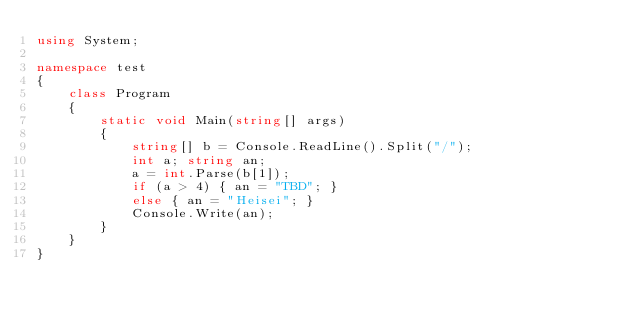<code> <loc_0><loc_0><loc_500><loc_500><_C#_>using System;

namespace test
{
    class Program
    {
        static void Main(string[] args)
        {
            string[] b = Console.ReadLine().Split("/");
            int a; string an;
            a = int.Parse(b[1]);
            if (a > 4) { an = "TBD"; }
            else { an = "Heisei"; }
            Console.Write(an);
        }
    }
}</code> 